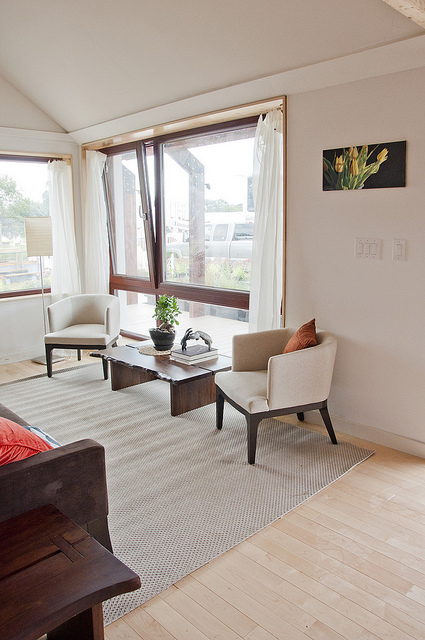<image>What kind of flowers are in the picture? I am not sure what kind of flowers are in the picture. It can be 'tulips', 'daffodils' or 'orchid'. What kind of flowers are in the picture? I am not sure what kind of flowers are in the picture. It can be seen tulips or daffodils. 